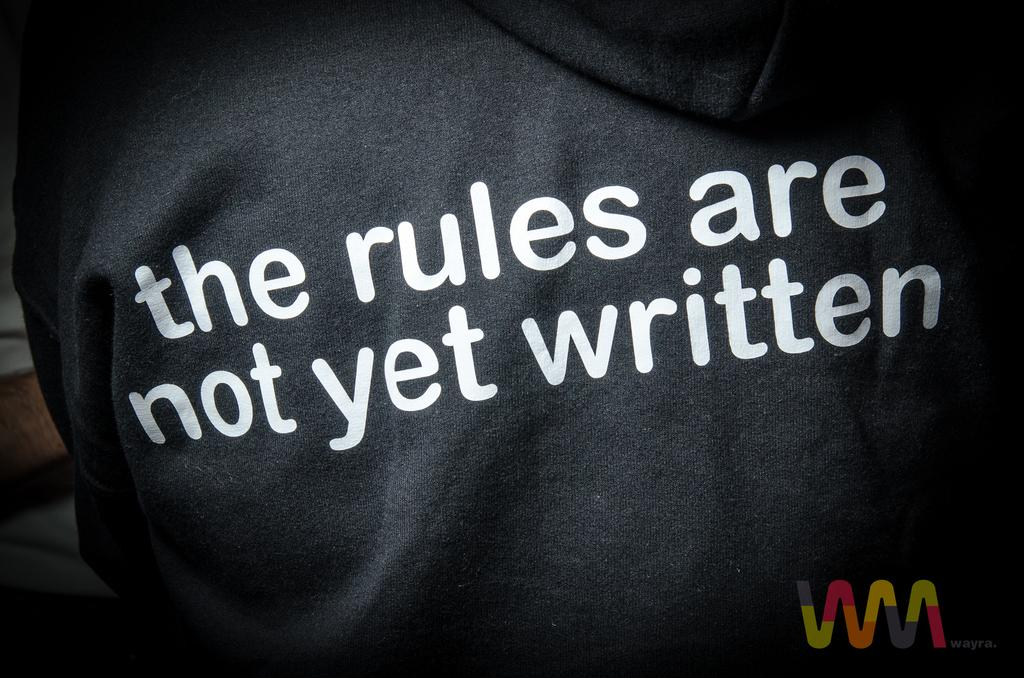What is the main color of the cloth in the image? The main color of the cloth in the image is black. What is written on the black cloth? Something is written on the black cloth in white color. Can you describe any additional features of the image? There is a watermark in the bottom right corner of the image. What type of thought can be seen floating in the air in the image? There is no thought or any floating objects visible in the image; it only features a black cloth with writing and a watermark. 